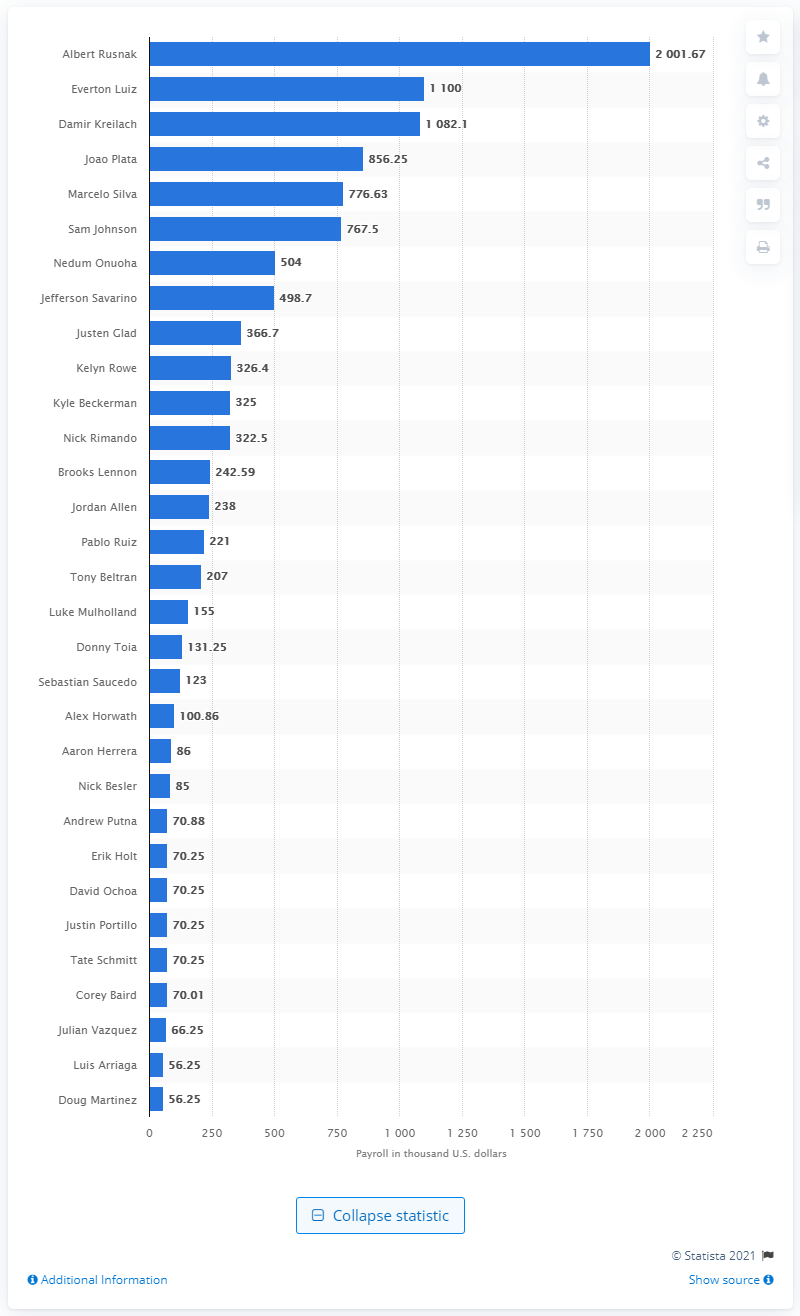Highlight a few significant elements in this photo. Albert Rusnak received a salary of two million dollars. 